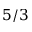Convert formula to latex. <formula><loc_0><loc_0><loc_500><loc_500>5 / 3</formula> 